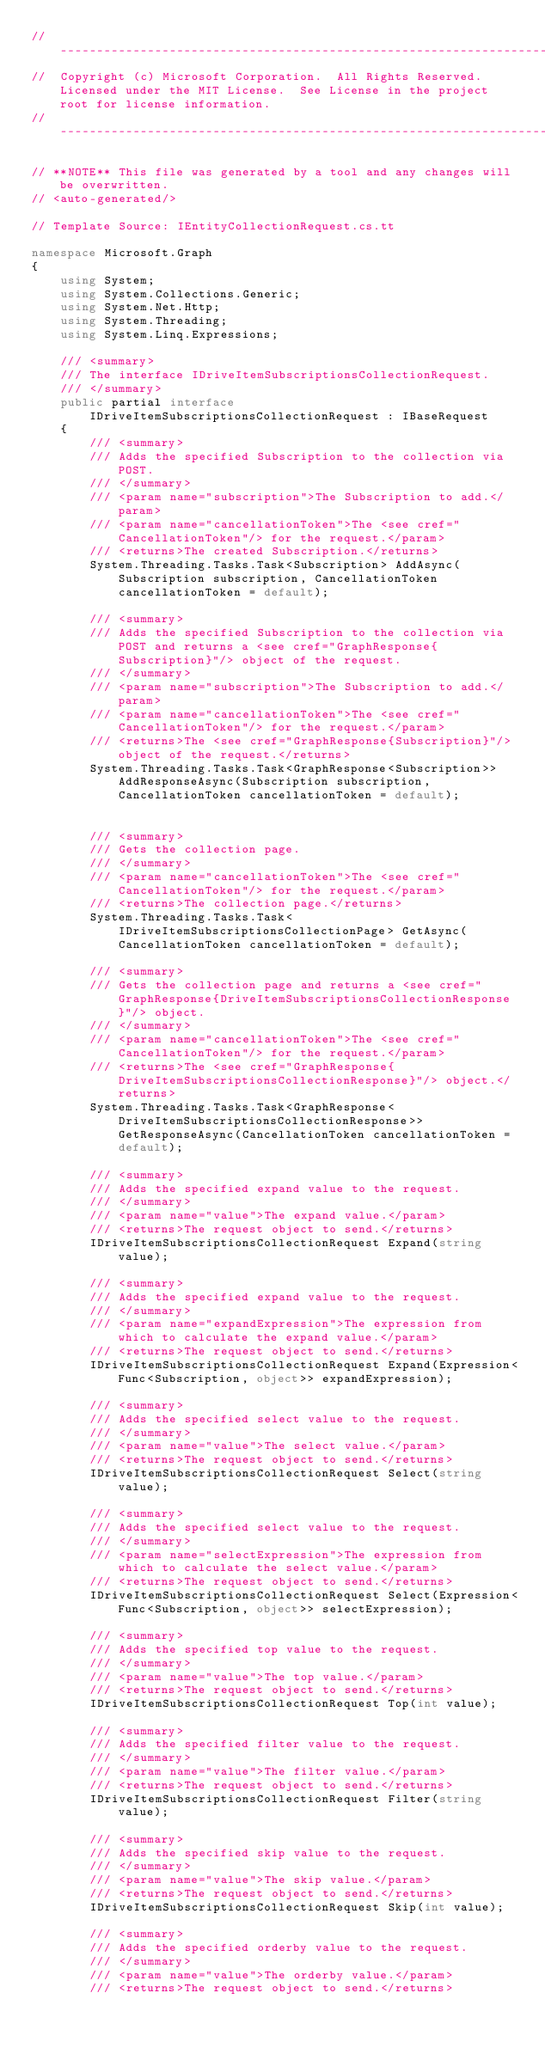<code> <loc_0><loc_0><loc_500><loc_500><_C#_>// ------------------------------------------------------------------------------
//  Copyright (c) Microsoft Corporation.  All Rights Reserved.  Licensed under the MIT License.  See License in the project root for license information.
// ------------------------------------------------------------------------------

// **NOTE** This file was generated by a tool and any changes will be overwritten.
// <auto-generated/>

// Template Source: IEntityCollectionRequest.cs.tt

namespace Microsoft.Graph
{
    using System;
    using System.Collections.Generic;
    using System.Net.Http;
    using System.Threading;
    using System.Linq.Expressions;

    /// <summary>
    /// The interface IDriveItemSubscriptionsCollectionRequest.
    /// </summary>
    public partial interface IDriveItemSubscriptionsCollectionRequest : IBaseRequest
    {
        /// <summary>
        /// Adds the specified Subscription to the collection via POST.
        /// </summary>
        /// <param name="subscription">The Subscription to add.</param>
        /// <param name="cancellationToken">The <see cref="CancellationToken"/> for the request.</param>
        /// <returns>The created Subscription.</returns>
        System.Threading.Tasks.Task<Subscription> AddAsync(Subscription subscription, CancellationToken cancellationToken = default);

        /// <summary>
        /// Adds the specified Subscription to the collection via POST and returns a <see cref="GraphResponse{Subscription}"/> object of the request.
        /// </summary>
        /// <param name="subscription">The Subscription to add.</param>
        /// <param name="cancellationToken">The <see cref="CancellationToken"/> for the request.</param>
        /// <returns>The <see cref="GraphResponse{Subscription}"/> object of the request.</returns>
        System.Threading.Tasks.Task<GraphResponse<Subscription>> AddResponseAsync(Subscription subscription, CancellationToken cancellationToken = default);


        /// <summary>
        /// Gets the collection page.
        /// </summary>
        /// <param name="cancellationToken">The <see cref="CancellationToken"/> for the request.</param>
        /// <returns>The collection page.</returns>
        System.Threading.Tasks.Task<IDriveItemSubscriptionsCollectionPage> GetAsync(CancellationToken cancellationToken = default);

        /// <summary>
        /// Gets the collection page and returns a <see cref="GraphResponse{DriveItemSubscriptionsCollectionResponse}"/> object.
        /// </summary>
        /// <param name="cancellationToken">The <see cref="CancellationToken"/> for the request.</param>
        /// <returns>The <see cref="GraphResponse{DriveItemSubscriptionsCollectionResponse}"/> object.</returns>
        System.Threading.Tasks.Task<GraphResponse<DriveItemSubscriptionsCollectionResponse>> GetResponseAsync(CancellationToken cancellationToken = default);

        /// <summary>
        /// Adds the specified expand value to the request.
        /// </summary>
        /// <param name="value">The expand value.</param>
        /// <returns>The request object to send.</returns>
        IDriveItemSubscriptionsCollectionRequest Expand(string value);

        /// <summary>
        /// Adds the specified expand value to the request.
        /// </summary>
        /// <param name="expandExpression">The expression from which to calculate the expand value.</param>
        /// <returns>The request object to send.</returns>
        IDriveItemSubscriptionsCollectionRequest Expand(Expression<Func<Subscription, object>> expandExpression);

        /// <summary>
        /// Adds the specified select value to the request.
        /// </summary>
        /// <param name="value">The select value.</param>
        /// <returns>The request object to send.</returns>
        IDriveItemSubscriptionsCollectionRequest Select(string value);

        /// <summary>
        /// Adds the specified select value to the request.
        /// </summary>
        /// <param name="selectExpression">The expression from which to calculate the select value.</param>
        /// <returns>The request object to send.</returns>
        IDriveItemSubscriptionsCollectionRequest Select(Expression<Func<Subscription, object>> selectExpression);

        /// <summary>
        /// Adds the specified top value to the request.
        /// </summary>
        /// <param name="value">The top value.</param>
        /// <returns>The request object to send.</returns>
        IDriveItemSubscriptionsCollectionRequest Top(int value);

        /// <summary>
        /// Adds the specified filter value to the request.
        /// </summary>
        /// <param name="value">The filter value.</param>
        /// <returns>The request object to send.</returns>
        IDriveItemSubscriptionsCollectionRequest Filter(string value);

        /// <summary>
        /// Adds the specified skip value to the request.
        /// </summary>
        /// <param name="value">The skip value.</param>
        /// <returns>The request object to send.</returns>
        IDriveItemSubscriptionsCollectionRequest Skip(int value);

        /// <summary>
        /// Adds the specified orderby value to the request.
        /// </summary>
        /// <param name="value">The orderby value.</param>
        /// <returns>The request object to send.</returns></code> 